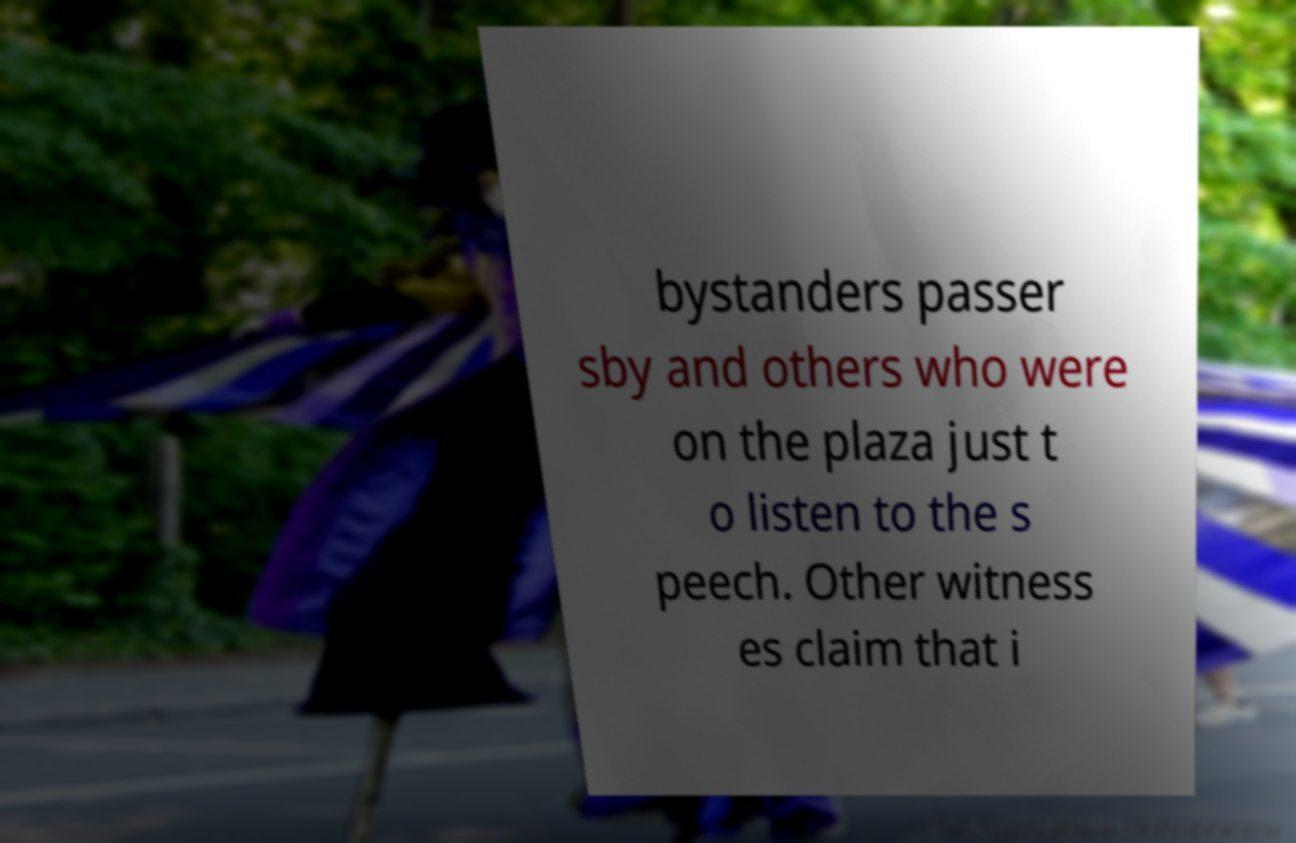Please read and relay the text visible in this image. What does it say? bystanders passer sby and others who were on the plaza just t o listen to the s peech. Other witness es claim that i 